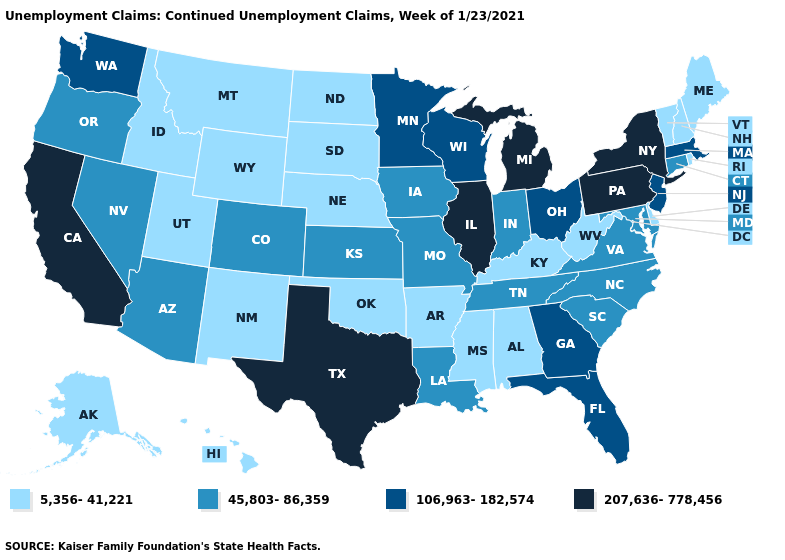Does South Dakota have the highest value in the MidWest?
Answer briefly. No. What is the lowest value in the South?
Be succinct. 5,356-41,221. Does Indiana have a higher value than North Dakota?
Give a very brief answer. Yes. What is the highest value in the West ?
Keep it brief. 207,636-778,456. What is the value of West Virginia?
Give a very brief answer. 5,356-41,221. Name the states that have a value in the range 45,803-86,359?
Short answer required. Arizona, Colorado, Connecticut, Indiana, Iowa, Kansas, Louisiana, Maryland, Missouri, Nevada, North Carolina, Oregon, South Carolina, Tennessee, Virginia. Does the map have missing data?
Write a very short answer. No. What is the lowest value in states that border Arkansas?
Answer briefly. 5,356-41,221. What is the highest value in the South ?
Answer briefly. 207,636-778,456. Name the states that have a value in the range 207,636-778,456?
Give a very brief answer. California, Illinois, Michigan, New York, Pennsylvania, Texas. What is the highest value in the West ?
Answer briefly. 207,636-778,456. What is the lowest value in states that border Alabama?
Give a very brief answer. 5,356-41,221. What is the value of South Dakota?
Answer briefly. 5,356-41,221. How many symbols are there in the legend?
Keep it brief. 4. Does Hawaii have the highest value in the West?
Keep it brief. No. 